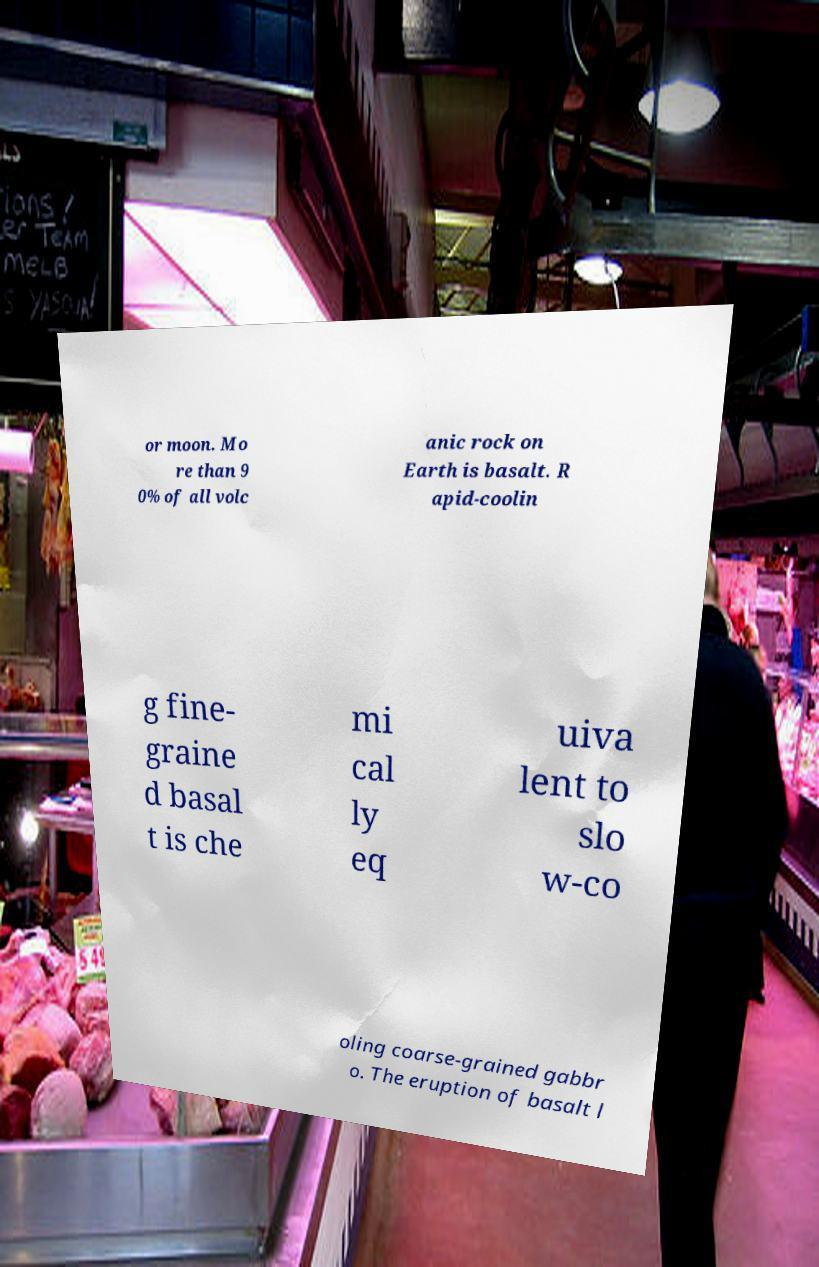I need the written content from this picture converted into text. Can you do that? or moon. Mo re than 9 0% of all volc anic rock on Earth is basalt. R apid-coolin g fine- graine d basal t is che mi cal ly eq uiva lent to slo w-co oling coarse-grained gabbr o. The eruption of basalt l 